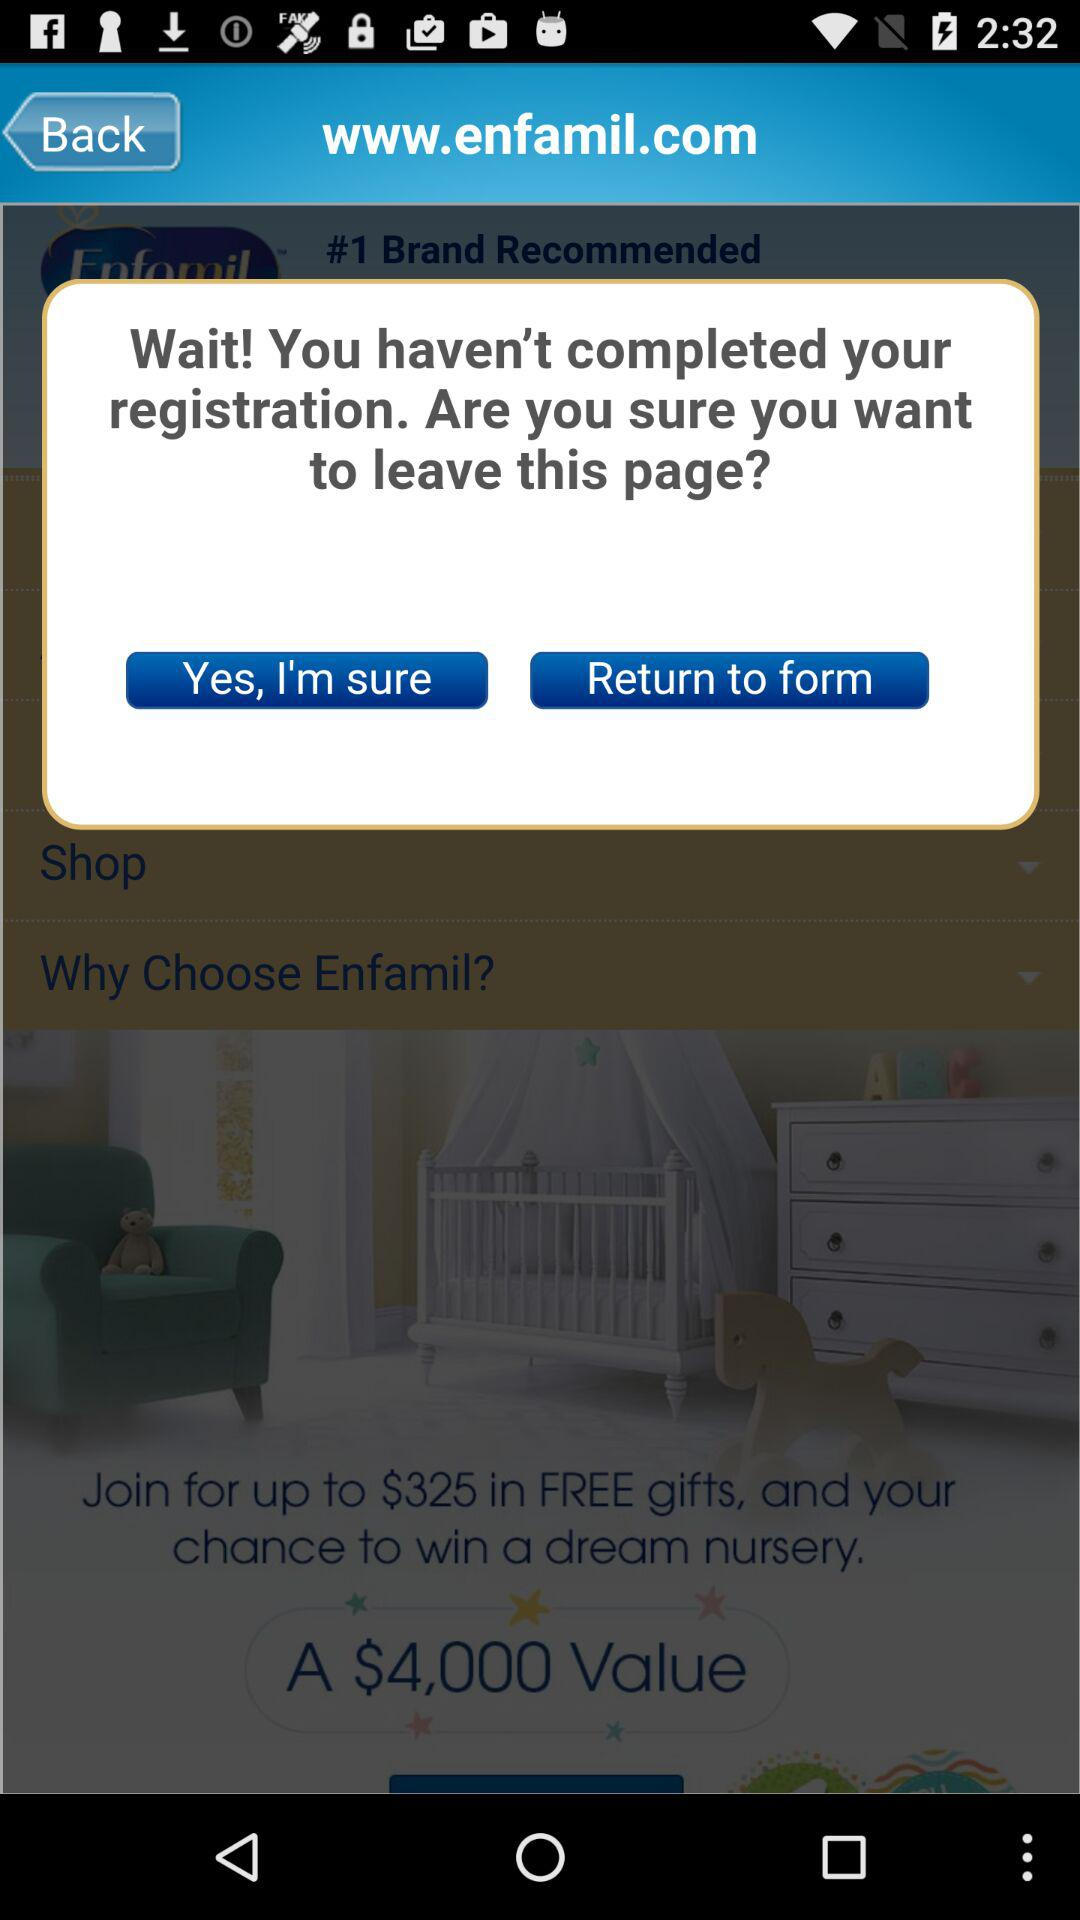What do I have a chance to win? You have a chance to win a dream nursery. 